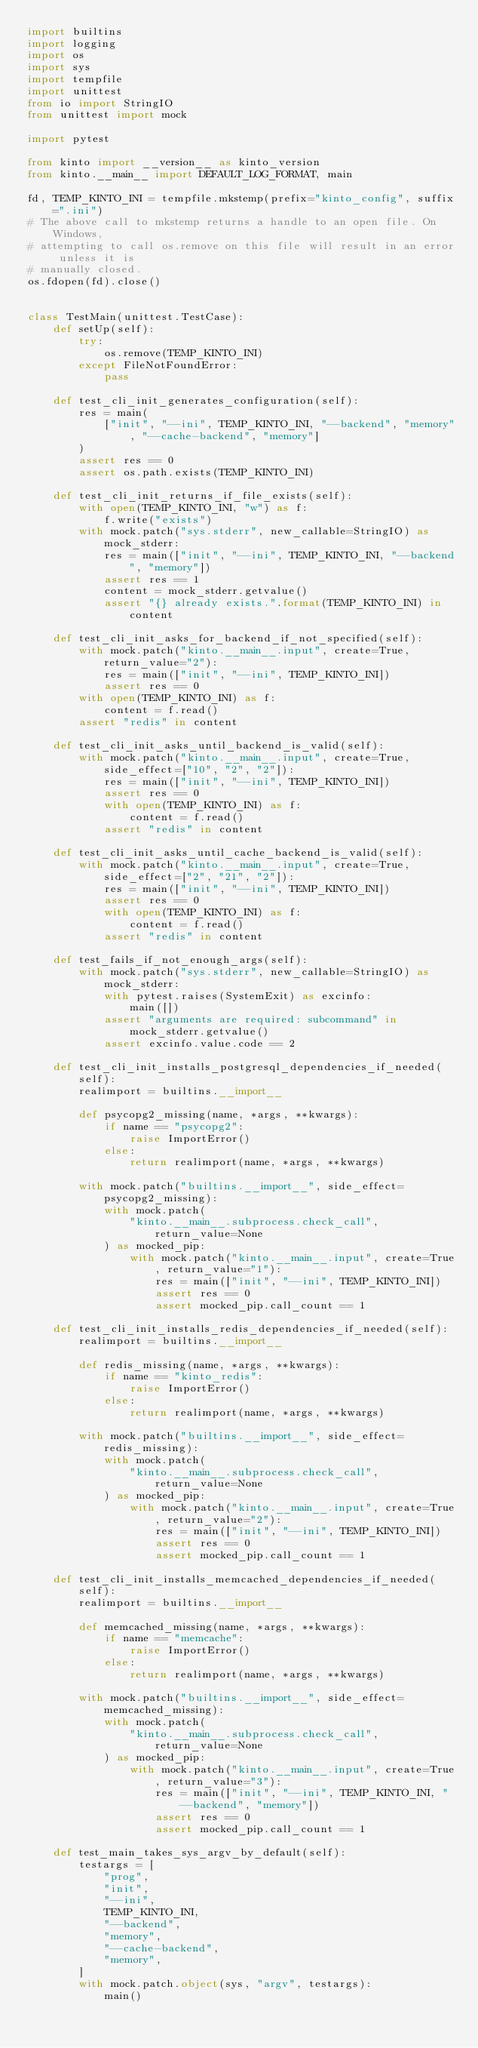Convert code to text. <code><loc_0><loc_0><loc_500><loc_500><_Python_>import builtins
import logging
import os
import sys
import tempfile
import unittest
from io import StringIO
from unittest import mock

import pytest

from kinto import __version__ as kinto_version
from kinto.__main__ import DEFAULT_LOG_FORMAT, main

fd, TEMP_KINTO_INI = tempfile.mkstemp(prefix="kinto_config", suffix=".ini")
# The above call to mkstemp returns a handle to an open file. On Windows,
# attempting to call os.remove on this file will result in an error unless it is
# manually closed.
os.fdopen(fd).close()


class TestMain(unittest.TestCase):
    def setUp(self):
        try:
            os.remove(TEMP_KINTO_INI)
        except FileNotFoundError:
            pass

    def test_cli_init_generates_configuration(self):
        res = main(
            ["init", "--ini", TEMP_KINTO_INI, "--backend", "memory", "--cache-backend", "memory"]
        )
        assert res == 0
        assert os.path.exists(TEMP_KINTO_INI)

    def test_cli_init_returns_if_file_exists(self):
        with open(TEMP_KINTO_INI, "w") as f:
            f.write("exists")
        with mock.patch("sys.stderr", new_callable=StringIO) as mock_stderr:
            res = main(["init", "--ini", TEMP_KINTO_INI, "--backend", "memory"])
            assert res == 1
            content = mock_stderr.getvalue()
            assert "{} already exists.".format(TEMP_KINTO_INI) in content

    def test_cli_init_asks_for_backend_if_not_specified(self):
        with mock.patch("kinto.__main__.input", create=True, return_value="2"):
            res = main(["init", "--ini", TEMP_KINTO_INI])
            assert res == 0
        with open(TEMP_KINTO_INI) as f:
            content = f.read()
        assert "redis" in content

    def test_cli_init_asks_until_backend_is_valid(self):
        with mock.patch("kinto.__main__.input", create=True, side_effect=["10", "2", "2"]):
            res = main(["init", "--ini", TEMP_KINTO_INI])
            assert res == 0
            with open(TEMP_KINTO_INI) as f:
                content = f.read()
            assert "redis" in content

    def test_cli_init_asks_until_cache_backend_is_valid(self):
        with mock.patch("kinto.__main__.input", create=True, side_effect=["2", "21", "2"]):
            res = main(["init", "--ini", TEMP_KINTO_INI])
            assert res == 0
            with open(TEMP_KINTO_INI) as f:
                content = f.read()
            assert "redis" in content

    def test_fails_if_not_enough_args(self):
        with mock.patch("sys.stderr", new_callable=StringIO) as mock_stderr:
            with pytest.raises(SystemExit) as excinfo:
                main([])
            assert "arguments are required: subcommand" in mock_stderr.getvalue()
            assert excinfo.value.code == 2

    def test_cli_init_installs_postgresql_dependencies_if_needed(self):
        realimport = builtins.__import__

        def psycopg2_missing(name, *args, **kwargs):
            if name == "psycopg2":
                raise ImportError()
            else:
                return realimport(name, *args, **kwargs)

        with mock.patch("builtins.__import__", side_effect=psycopg2_missing):
            with mock.patch(
                "kinto.__main__.subprocess.check_call", return_value=None
            ) as mocked_pip:
                with mock.patch("kinto.__main__.input", create=True, return_value="1"):
                    res = main(["init", "--ini", TEMP_KINTO_INI])
                    assert res == 0
                    assert mocked_pip.call_count == 1

    def test_cli_init_installs_redis_dependencies_if_needed(self):
        realimport = builtins.__import__

        def redis_missing(name, *args, **kwargs):
            if name == "kinto_redis":
                raise ImportError()
            else:
                return realimport(name, *args, **kwargs)

        with mock.patch("builtins.__import__", side_effect=redis_missing):
            with mock.patch(
                "kinto.__main__.subprocess.check_call", return_value=None
            ) as mocked_pip:
                with mock.patch("kinto.__main__.input", create=True, return_value="2"):
                    res = main(["init", "--ini", TEMP_KINTO_INI])
                    assert res == 0
                    assert mocked_pip.call_count == 1

    def test_cli_init_installs_memcached_dependencies_if_needed(self):
        realimport = builtins.__import__

        def memcached_missing(name, *args, **kwargs):
            if name == "memcache":
                raise ImportError()
            else:
                return realimport(name, *args, **kwargs)

        with mock.patch("builtins.__import__", side_effect=memcached_missing):
            with mock.patch(
                "kinto.__main__.subprocess.check_call", return_value=None
            ) as mocked_pip:
                with mock.patch("kinto.__main__.input", create=True, return_value="3"):
                    res = main(["init", "--ini", TEMP_KINTO_INI, "--backend", "memory"])
                    assert res == 0
                    assert mocked_pip.call_count == 1

    def test_main_takes_sys_argv_by_default(self):
        testargs = [
            "prog",
            "init",
            "--ini",
            TEMP_KINTO_INI,
            "--backend",
            "memory",
            "--cache-backend",
            "memory",
        ]
        with mock.patch.object(sys, "argv", testargs):
            main()
</code> 